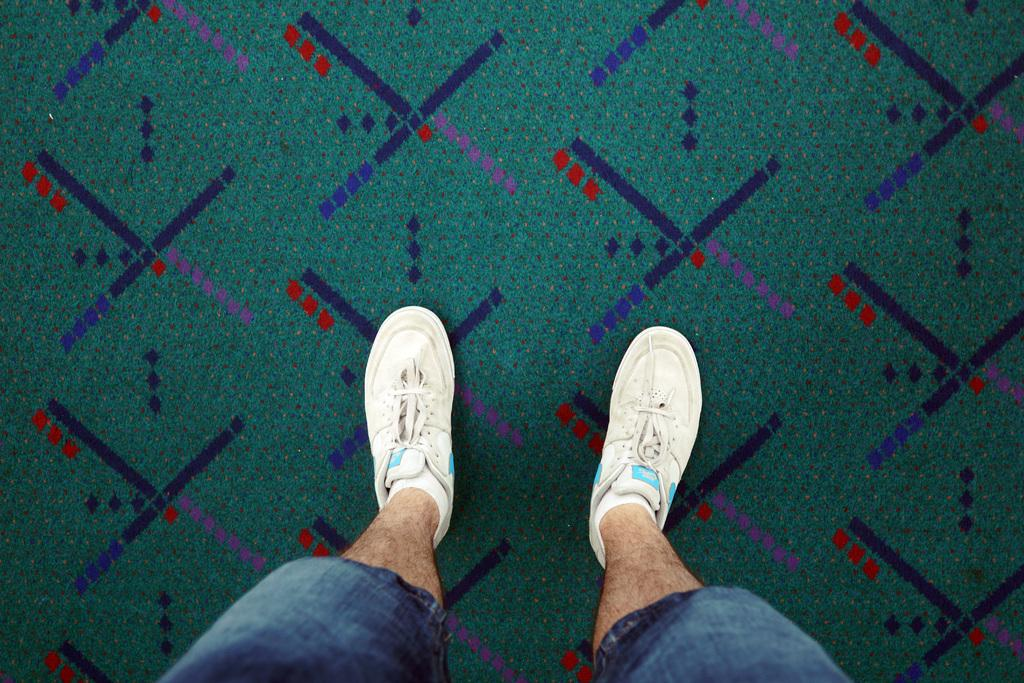What is present in the image? There is a person in the image. What is the person standing on? The person is standing on a carpet. What type of shoes is the person wearing? The person is wearing white shoes. What part of the person can be seen in the image? Only the legs of the person are visible in the image. What is the caption of the image? There is no caption present in the image, as it is a photograph and not a text-based medium. 